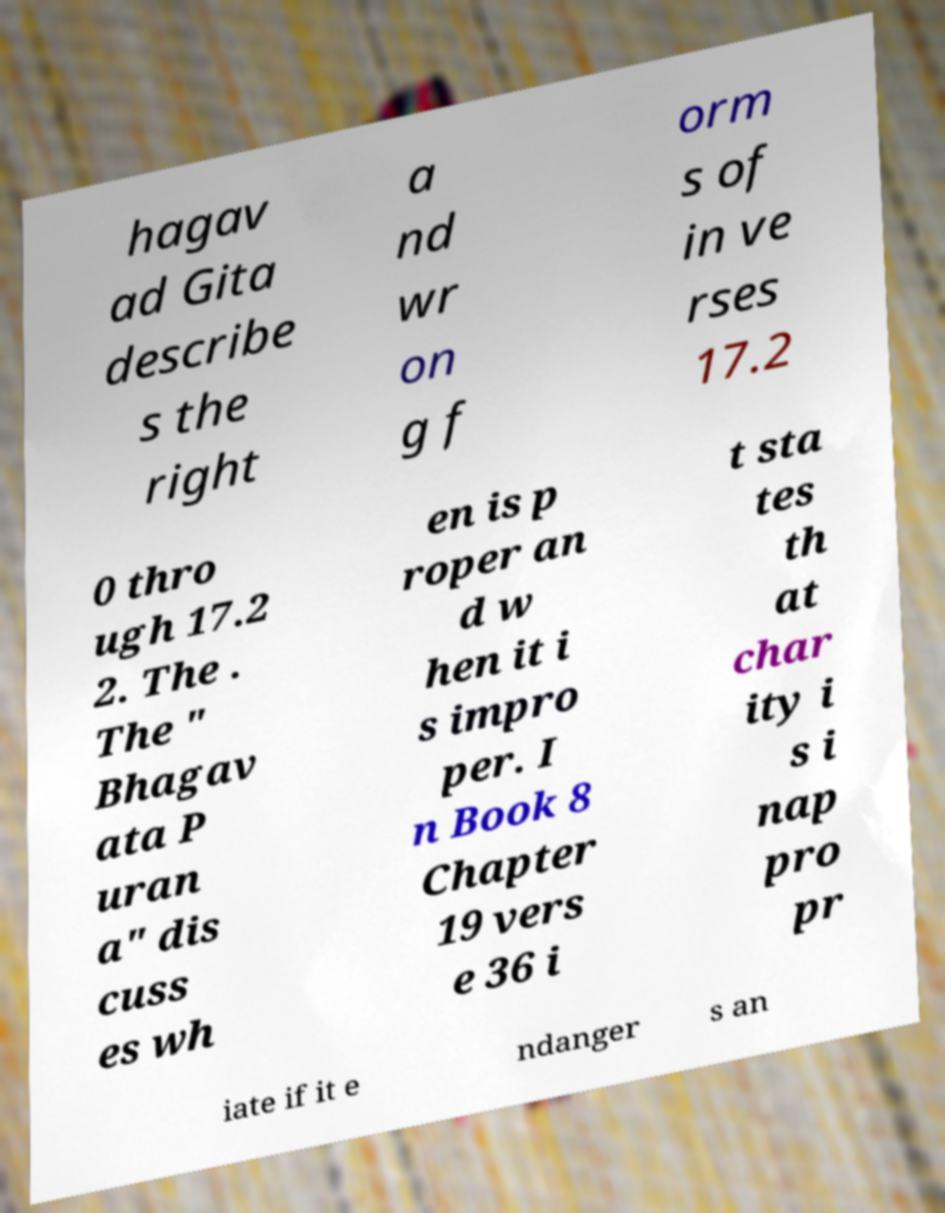Could you assist in decoding the text presented in this image and type it out clearly? hagav ad Gita describe s the right a nd wr on g f orm s of in ve rses 17.2 0 thro ugh 17.2 2. The . The " Bhagav ata P uran a" dis cuss es wh en is p roper an d w hen it i s impro per. I n Book 8 Chapter 19 vers e 36 i t sta tes th at char ity i s i nap pro pr iate if it e ndanger s an 